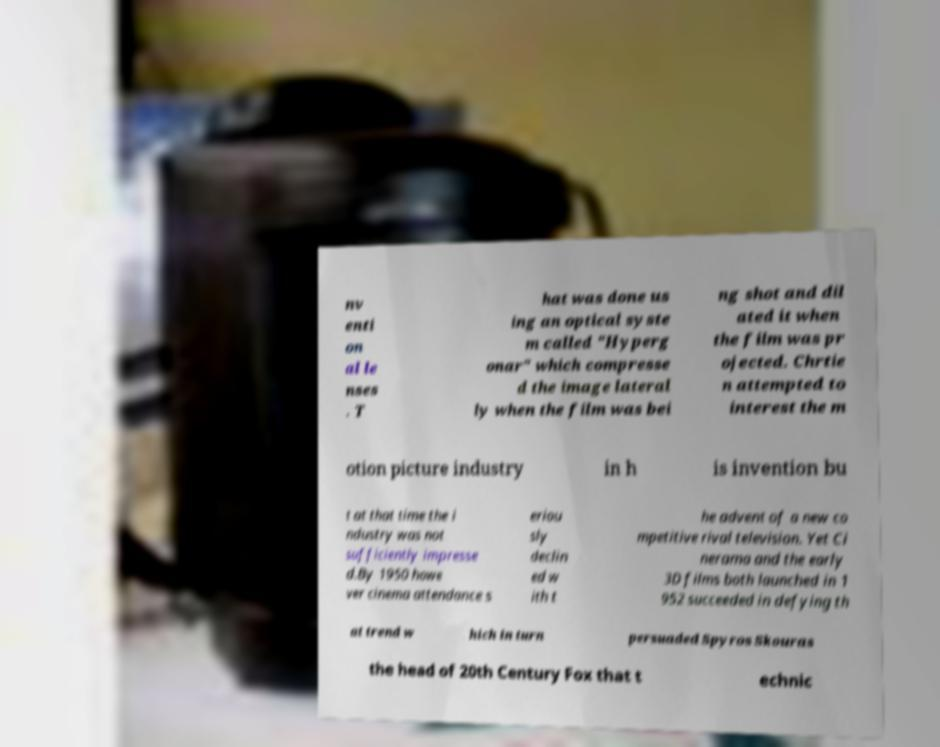I need the written content from this picture converted into text. Can you do that? nv enti on al le nses . T hat was done us ing an optical syste m called "Hyperg onar" which compresse d the image lateral ly when the film was bei ng shot and dil ated it when the film was pr ojected. Chrtie n attempted to interest the m otion picture industry in h is invention bu t at that time the i ndustry was not sufficiently impresse d.By 1950 howe ver cinema attendance s eriou sly declin ed w ith t he advent of a new co mpetitive rival television. Yet Ci nerama and the early 3D films both launched in 1 952 succeeded in defying th at trend w hich in turn persuaded Spyros Skouras the head of 20th Century Fox that t echnic 